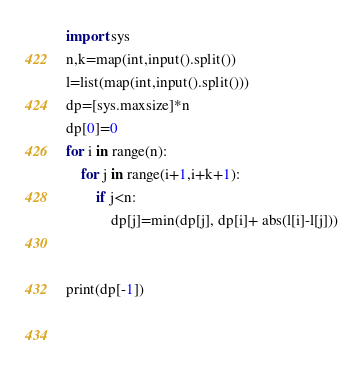<code> <loc_0><loc_0><loc_500><loc_500><_Python_>import sys
n,k=map(int,input().split())
l=list(map(int,input().split()))
dp=[sys.maxsize]*n
dp[0]=0
for i in range(n):
    for j in range(i+1,i+k+1):
        if j<n:
            dp[j]=min(dp[j], dp[i]+ abs(l[i]-l[j]))


print(dp[-1])
    
    
</code> 